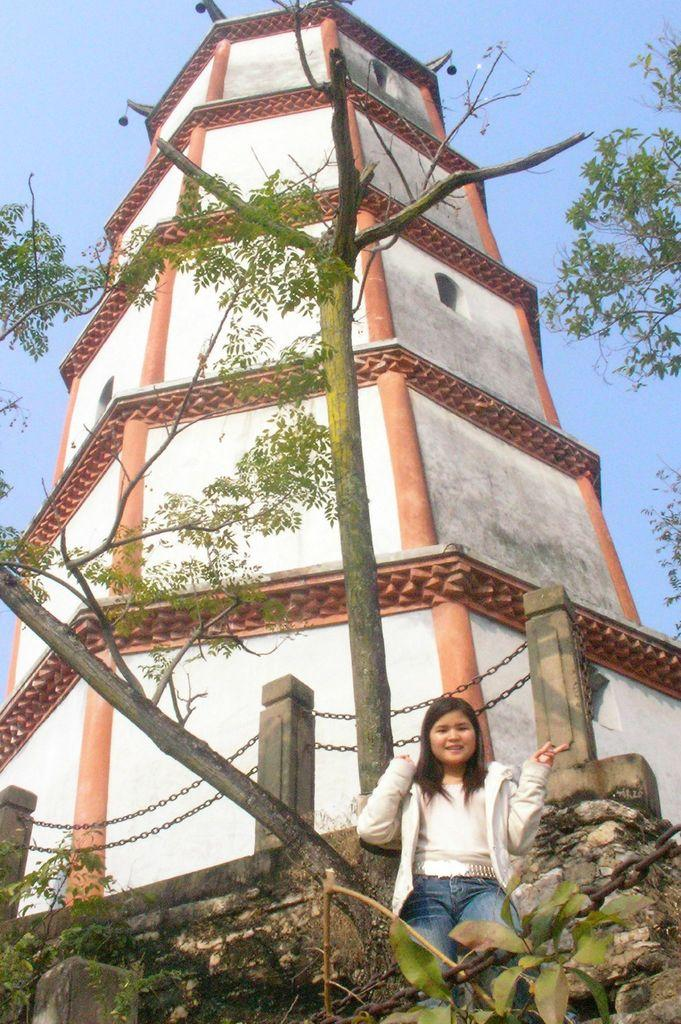What type of structure is visible in the image? There is a building in the image. What architectural features can be seen on the building? There are pillars in the image. What object is attached to the building? There is a chain in the image. What type of natural environment is visible in the image? There are trees in the image. What is the color of the sky in the image? The sky is pale blue in the image. Who is present in the image? There is a woman in the image. What is the woman doing in the image? The woman is standing. What is the woman wearing in the image? The woman is wearing clothes. What is the woman's facial expression in the image? The woman is smiling. What type of lock is securing the truck in the image? There is no truck present in the image, so it is not possible to determine what type of lock might be securing it. 